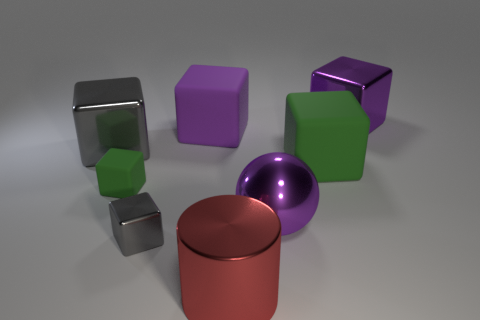Subtract all gray cubes. How many cubes are left? 4 Subtract all small blocks. How many blocks are left? 4 Subtract all red cubes. Subtract all yellow balls. How many cubes are left? 6 Add 1 red objects. How many objects exist? 9 Subtract all cylinders. How many objects are left? 7 Add 4 big purple rubber things. How many big purple rubber things exist? 5 Subtract 0 red spheres. How many objects are left? 8 Subtract all purple blocks. Subtract all metallic things. How many objects are left? 1 Add 2 big gray things. How many big gray things are left? 3 